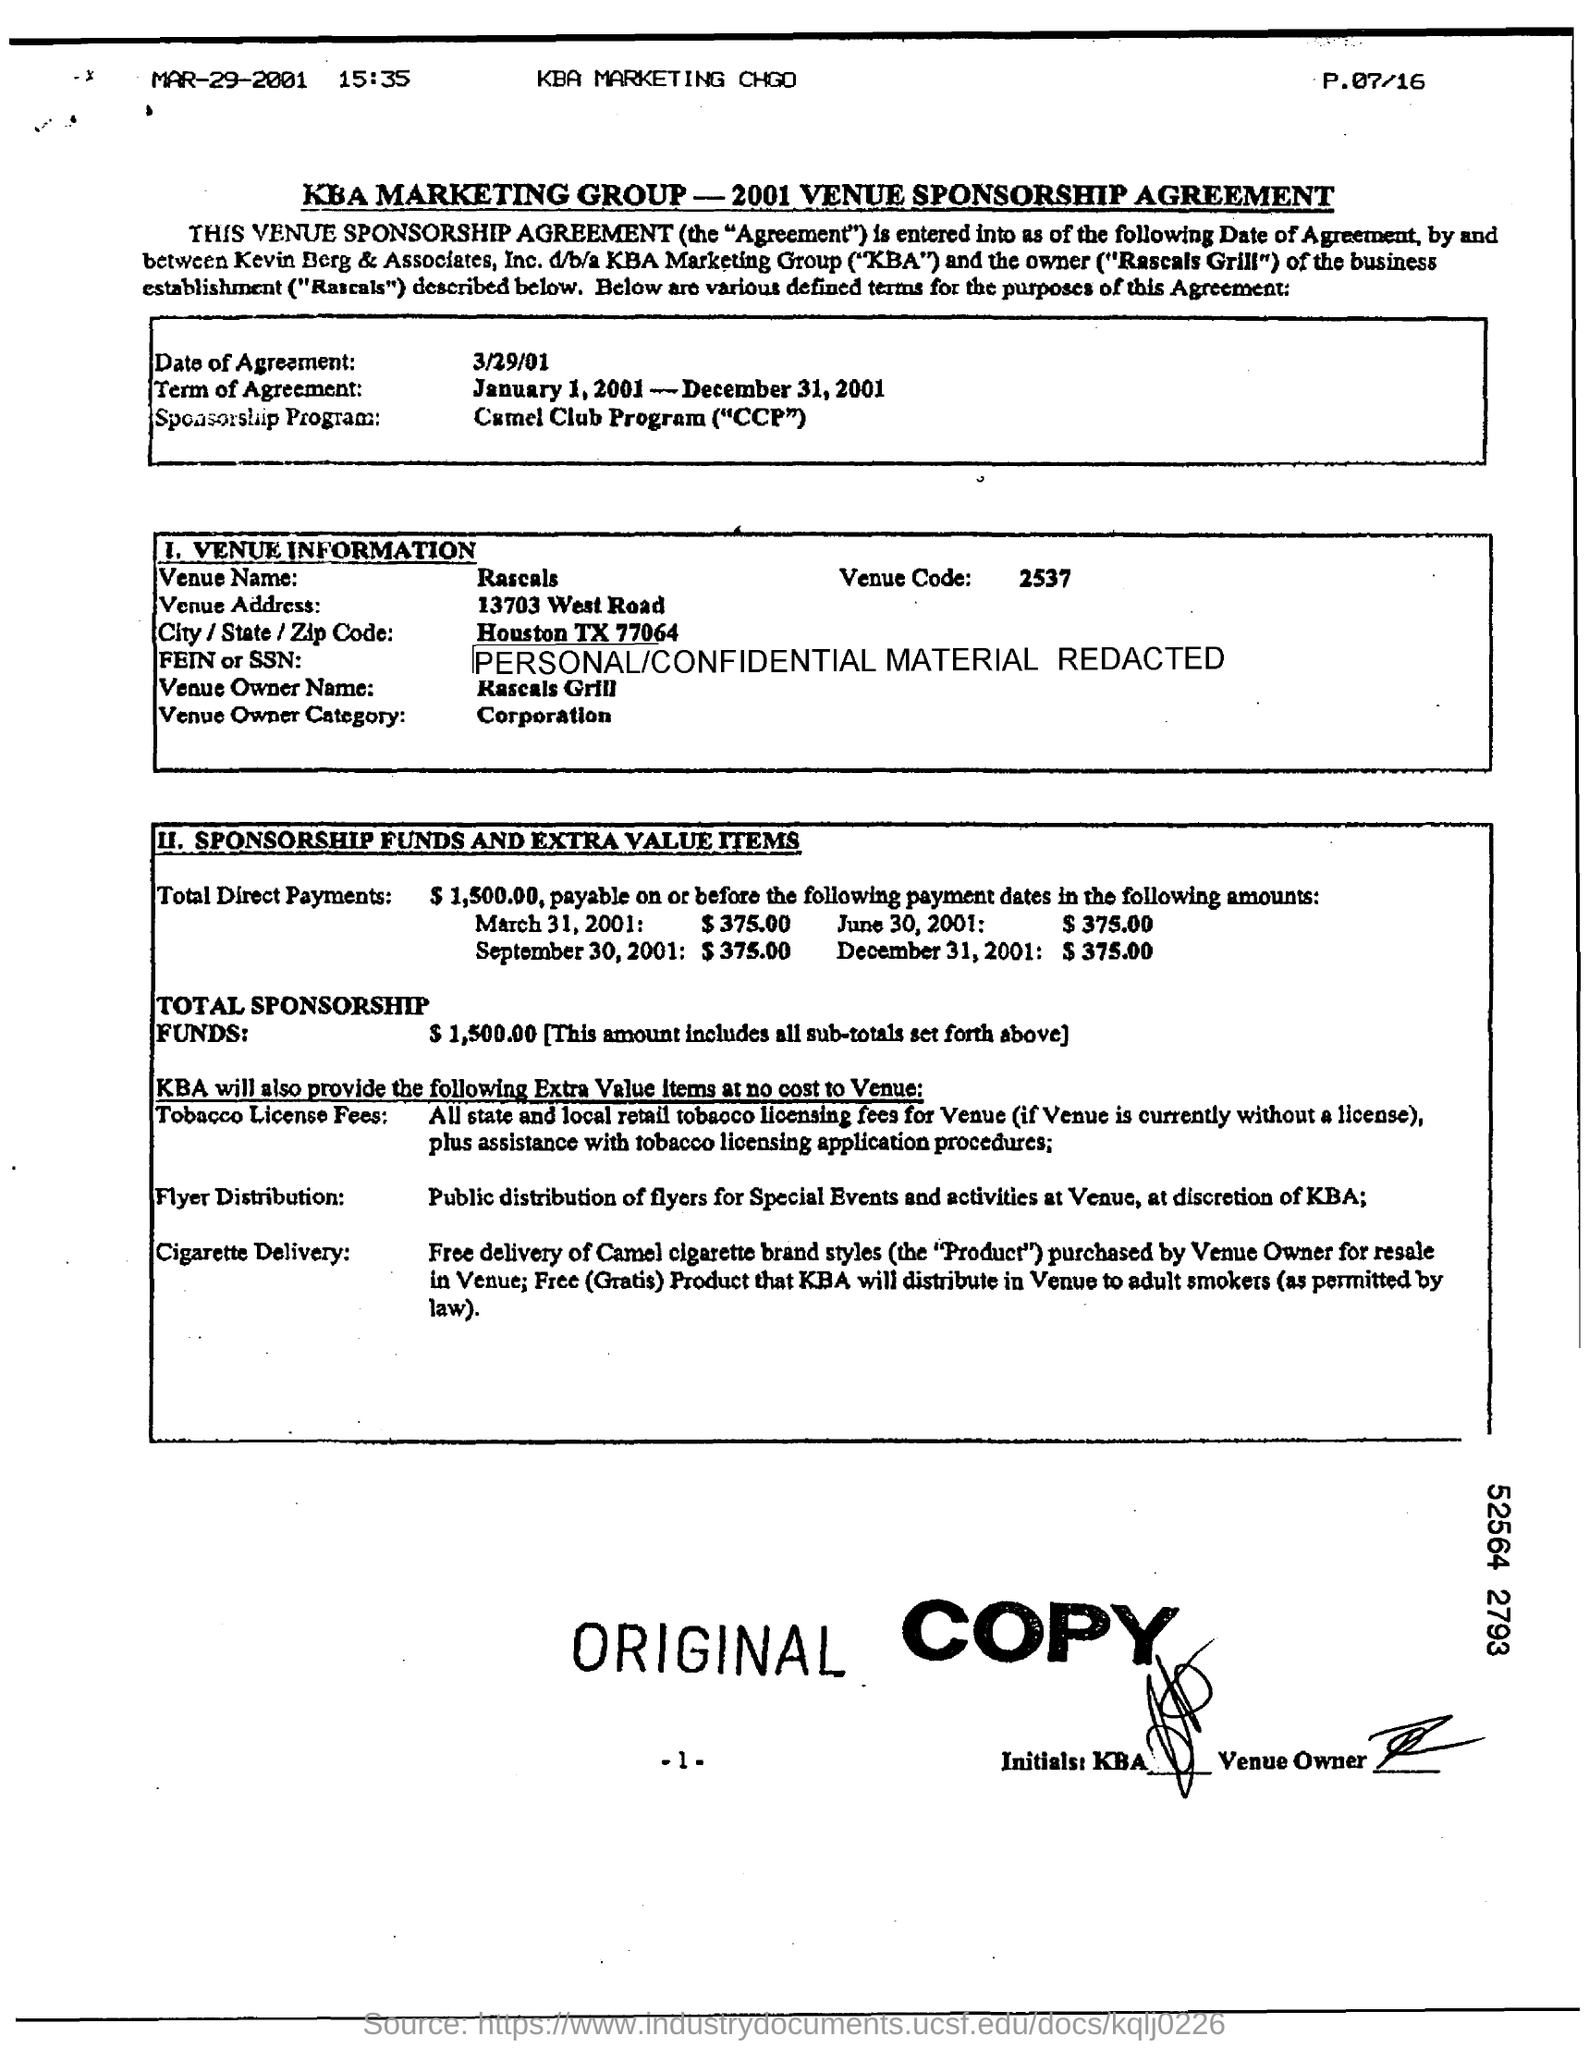When is the Date of Agreement?
Your answer should be compact. 3/29/01. What is the Term of Agreement?
Ensure brevity in your answer.  January 1, 2001 - December 31, 2001. What is the Venue Name?
Make the answer very short. Rascals. What is the Venue Code?
Your answer should be compact. 2537. What is the Venue Owner Name?
Provide a succinct answer. Rascals Grill. What is the Venue Owner Category?
Your answer should be compact. Corporation. 